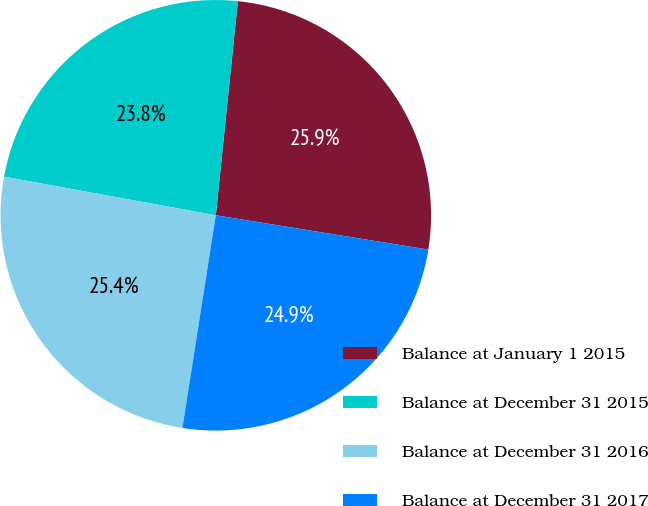Convert chart. <chart><loc_0><loc_0><loc_500><loc_500><pie_chart><fcel>Balance at January 1 2015<fcel>Balance at December 31 2015<fcel>Balance at December 31 2016<fcel>Balance at December 31 2017<nl><fcel>25.91%<fcel>23.76%<fcel>25.39%<fcel>24.93%<nl></chart> 